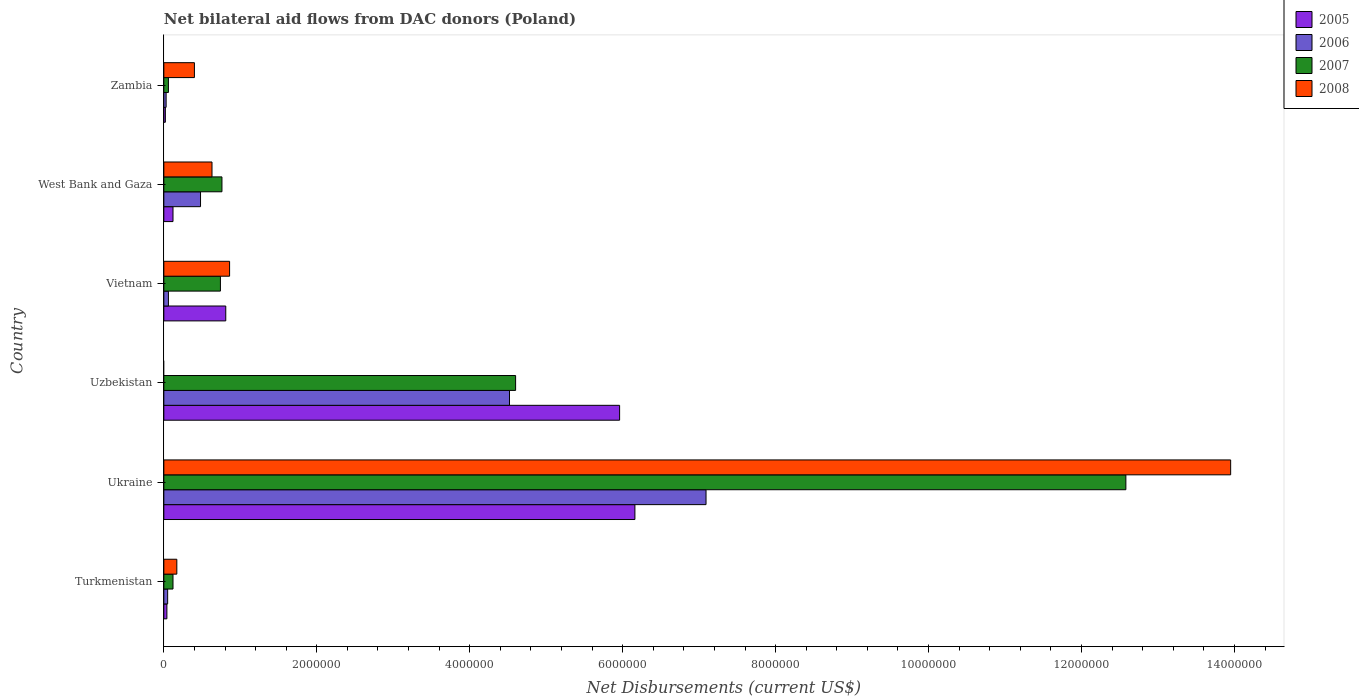How many different coloured bars are there?
Give a very brief answer. 4. Are the number of bars per tick equal to the number of legend labels?
Your answer should be compact. No. What is the label of the 1st group of bars from the top?
Make the answer very short. Zambia. What is the net bilateral aid flows in 2007 in West Bank and Gaza?
Give a very brief answer. 7.60e+05. Across all countries, what is the maximum net bilateral aid flows in 2008?
Provide a succinct answer. 1.40e+07. In which country was the net bilateral aid flows in 2005 maximum?
Provide a short and direct response. Ukraine. What is the total net bilateral aid flows in 2008 in the graph?
Provide a succinct answer. 1.60e+07. What is the difference between the net bilateral aid flows in 2006 in Uzbekistan and the net bilateral aid flows in 2007 in Vietnam?
Your answer should be compact. 3.78e+06. What is the average net bilateral aid flows in 2005 per country?
Offer a terse response. 2.18e+06. What is the difference between the net bilateral aid flows in 2008 and net bilateral aid flows in 2007 in Ukraine?
Provide a short and direct response. 1.37e+06. In how many countries, is the net bilateral aid flows in 2005 greater than 4000000 US$?
Give a very brief answer. 2. What is the ratio of the net bilateral aid flows in 2006 in Turkmenistan to that in Zambia?
Your answer should be compact. 1.67. Is the difference between the net bilateral aid flows in 2008 in West Bank and Gaza and Zambia greater than the difference between the net bilateral aid flows in 2007 in West Bank and Gaza and Zambia?
Provide a short and direct response. No. What is the difference between the highest and the second highest net bilateral aid flows in 2006?
Your response must be concise. 2.57e+06. What is the difference between the highest and the lowest net bilateral aid flows in 2007?
Ensure brevity in your answer.  1.25e+07. How many bars are there?
Keep it short and to the point. 23. Are all the bars in the graph horizontal?
Ensure brevity in your answer.  Yes. How many countries are there in the graph?
Provide a succinct answer. 6. What is the difference between two consecutive major ticks on the X-axis?
Ensure brevity in your answer.  2.00e+06. Are the values on the major ticks of X-axis written in scientific E-notation?
Make the answer very short. No. Does the graph contain any zero values?
Ensure brevity in your answer.  Yes. How many legend labels are there?
Make the answer very short. 4. How are the legend labels stacked?
Offer a very short reply. Vertical. What is the title of the graph?
Offer a very short reply. Net bilateral aid flows from DAC donors (Poland). Does "1963" appear as one of the legend labels in the graph?
Your answer should be compact. No. What is the label or title of the X-axis?
Offer a terse response. Net Disbursements (current US$). What is the Net Disbursements (current US$) of 2008 in Turkmenistan?
Your response must be concise. 1.70e+05. What is the Net Disbursements (current US$) in 2005 in Ukraine?
Provide a succinct answer. 6.16e+06. What is the Net Disbursements (current US$) in 2006 in Ukraine?
Keep it short and to the point. 7.09e+06. What is the Net Disbursements (current US$) in 2007 in Ukraine?
Your answer should be very brief. 1.26e+07. What is the Net Disbursements (current US$) in 2008 in Ukraine?
Your answer should be compact. 1.40e+07. What is the Net Disbursements (current US$) in 2005 in Uzbekistan?
Make the answer very short. 5.96e+06. What is the Net Disbursements (current US$) of 2006 in Uzbekistan?
Provide a succinct answer. 4.52e+06. What is the Net Disbursements (current US$) of 2007 in Uzbekistan?
Offer a terse response. 4.60e+06. What is the Net Disbursements (current US$) of 2005 in Vietnam?
Give a very brief answer. 8.10e+05. What is the Net Disbursements (current US$) in 2006 in Vietnam?
Give a very brief answer. 6.00e+04. What is the Net Disbursements (current US$) of 2007 in Vietnam?
Provide a succinct answer. 7.40e+05. What is the Net Disbursements (current US$) in 2008 in Vietnam?
Ensure brevity in your answer.  8.60e+05. What is the Net Disbursements (current US$) in 2007 in West Bank and Gaza?
Your answer should be very brief. 7.60e+05. What is the Net Disbursements (current US$) in 2008 in West Bank and Gaza?
Make the answer very short. 6.30e+05. What is the Net Disbursements (current US$) of 2005 in Zambia?
Your response must be concise. 2.00e+04. What is the Net Disbursements (current US$) of 2006 in Zambia?
Ensure brevity in your answer.  3.00e+04. What is the Net Disbursements (current US$) in 2008 in Zambia?
Your answer should be very brief. 4.00e+05. Across all countries, what is the maximum Net Disbursements (current US$) in 2005?
Ensure brevity in your answer.  6.16e+06. Across all countries, what is the maximum Net Disbursements (current US$) of 2006?
Ensure brevity in your answer.  7.09e+06. Across all countries, what is the maximum Net Disbursements (current US$) in 2007?
Give a very brief answer. 1.26e+07. Across all countries, what is the maximum Net Disbursements (current US$) in 2008?
Your answer should be very brief. 1.40e+07. Across all countries, what is the minimum Net Disbursements (current US$) of 2005?
Give a very brief answer. 2.00e+04. Across all countries, what is the minimum Net Disbursements (current US$) in 2006?
Provide a succinct answer. 3.00e+04. What is the total Net Disbursements (current US$) in 2005 in the graph?
Provide a succinct answer. 1.31e+07. What is the total Net Disbursements (current US$) of 2006 in the graph?
Your answer should be very brief. 1.22e+07. What is the total Net Disbursements (current US$) of 2007 in the graph?
Ensure brevity in your answer.  1.89e+07. What is the total Net Disbursements (current US$) of 2008 in the graph?
Provide a short and direct response. 1.60e+07. What is the difference between the Net Disbursements (current US$) of 2005 in Turkmenistan and that in Ukraine?
Your response must be concise. -6.12e+06. What is the difference between the Net Disbursements (current US$) of 2006 in Turkmenistan and that in Ukraine?
Ensure brevity in your answer.  -7.04e+06. What is the difference between the Net Disbursements (current US$) of 2007 in Turkmenistan and that in Ukraine?
Provide a short and direct response. -1.25e+07. What is the difference between the Net Disbursements (current US$) of 2008 in Turkmenistan and that in Ukraine?
Provide a short and direct response. -1.38e+07. What is the difference between the Net Disbursements (current US$) of 2005 in Turkmenistan and that in Uzbekistan?
Provide a short and direct response. -5.92e+06. What is the difference between the Net Disbursements (current US$) in 2006 in Turkmenistan and that in Uzbekistan?
Your answer should be compact. -4.47e+06. What is the difference between the Net Disbursements (current US$) of 2007 in Turkmenistan and that in Uzbekistan?
Your answer should be compact. -4.48e+06. What is the difference between the Net Disbursements (current US$) in 2005 in Turkmenistan and that in Vietnam?
Offer a very short reply. -7.70e+05. What is the difference between the Net Disbursements (current US$) in 2006 in Turkmenistan and that in Vietnam?
Your answer should be very brief. -10000. What is the difference between the Net Disbursements (current US$) in 2007 in Turkmenistan and that in Vietnam?
Provide a short and direct response. -6.20e+05. What is the difference between the Net Disbursements (current US$) in 2008 in Turkmenistan and that in Vietnam?
Ensure brevity in your answer.  -6.90e+05. What is the difference between the Net Disbursements (current US$) of 2006 in Turkmenistan and that in West Bank and Gaza?
Give a very brief answer. -4.30e+05. What is the difference between the Net Disbursements (current US$) in 2007 in Turkmenistan and that in West Bank and Gaza?
Give a very brief answer. -6.40e+05. What is the difference between the Net Disbursements (current US$) of 2008 in Turkmenistan and that in West Bank and Gaza?
Give a very brief answer. -4.60e+05. What is the difference between the Net Disbursements (current US$) in 2005 in Turkmenistan and that in Zambia?
Offer a very short reply. 2.00e+04. What is the difference between the Net Disbursements (current US$) of 2006 in Turkmenistan and that in Zambia?
Your answer should be compact. 2.00e+04. What is the difference between the Net Disbursements (current US$) of 2008 in Turkmenistan and that in Zambia?
Ensure brevity in your answer.  -2.30e+05. What is the difference between the Net Disbursements (current US$) in 2005 in Ukraine and that in Uzbekistan?
Offer a very short reply. 2.00e+05. What is the difference between the Net Disbursements (current US$) of 2006 in Ukraine and that in Uzbekistan?
Your answer should be compact. 2.57e+06. What is the difference between the Net Disbursements (current US$) of 2007 in Ukraine and that in Uzbekistan?
Your response must be concise. 7.98e+06. What is the difference between the Net Disbursements (current US$) of 2005 in Ukraine and that in Vietnam?
Give a very brief answer. 5.35e+06. What is the difference between the Net Disbursements (current US$) of 2006 in Ukraine and that in Vietnam?
Ensure brevity in your answer.  7.03e+06. What is the difference between the Net Disbursements (current US$) in 2007 in Ukraine and that in Vietnam?
Offer a very short reply. 1.18e+07. What is the difference between the Net Disbursements (current US$) of 2008 in Ukraine and that in Vietnam?
Offer a terse response. 1.31e+07. What is the difference between the Net Disbursements (current US$) in 2005 in Ukraine and that in West Bank and Gaza?
Make the answer very short. 6.04e+06. What is the difference between the Net Disbursements (current US$) in 2006 in Ukraine and that in West Bank and Gaza?
Offer a very short reply. 6.61e+06. What is the difference between the Net Disbursements (current US$) of 2007 in Ukraine and that in West Bank and Gaza?
Your response must be concise. 1.18e+07. What is the difference between the Net Disbursements (current US$) in 2008 in Ukraine and that in West Bank and Gaza?
Provide a succinct answer. 1.33e+07. What is the difference between the Net Disbursements (current US$) in 2005 in Ukraine and that in Zambia?
Your response must be concise. 6.14e+06. What is the difference between the Net Disbursements (current US$) in 2006 in Ukraine and that in Zambia?
Make the answer very short. 7.06e+06. What is the difference between the Net Disbursements (current US$) of 2007 in Ukraine and that in Zambia?
Your answer should be very brief. 1.25e+07. What is the difference between the Net Disbursements (current US$) in 2008 in Ukraine and that in Zambia?
Your answer should be compact. 1.36e+07. What is the difference between the Net Disbursements (current US$) in 2005 in Uzbekistan and that in Vietnam?
Your response must be concise. 5.15e+06. What is the difference between the Net Disbursements (current US$) in 2006 in Uzbekistan and that in Vietnam?
Ensure brevity in your answer.  4.46e+06. What is the difference between the Net Disbursements (current US$) of 2007 in Uzbekistan and that in Vietnam?
Make the answer very short. 3.86e+06. What is the difference between the Net Disbursements (current US$) of 2005 in Uzbekistan and that in West Bank and Gaza?
Offer a very short reply. 5.84e+06. What is the difference between the Net Disbursements (current US$) in 2006 in Uzbekistan and that in West Bank and Gaza?
Offer a terse response. 4.04e+06. What is the difference between the Net Disbursements (current US$) of 2007 in Uzbekistan and that in West Bank and Gaza?
Your answer should be compact. 3.84e+06. What is the difference between the Net Disbursements (current US$) in 2005 in Uzbekistan and that in Zambia?
Provide a short and direct response. 5.94e+06. What is the difference between the Net Disbursements (current US$) of 2006 in Uzbekistan and that in Zambia?
Your response must be concise. 4.49e+06. What is the difference between the Net Disbursements (current US$) of 2007 in Uzbekistan and that in Zambia?
Your response must be concise. 4.54e+06. What is the difference between the Net Disbursements (current US$) in 2005 in Vietnam and that in West Bank and Gaza?
Offer a very short reply. 6.90e+05. What is the difference between the Net Disbursements (current US$) of 2006 in Vietnam and that in West Bank and Gaza?
Your answer should be very brief. -4.20e+05. What is the difference between the Net Disbursements (current US$) in 2007 in Vietnam and that in West Bank and Gaza?
Your answer should be very brief. -2.00e+04. What is the difference between the Net Disbursements (current US$) in 2008 in Vietnam and that in West Bank and Gaza?
Provide a short and direct response. 2.30e+05. What is the difference between the Net Disbursements (current US$) of 2005 in Vietnam and that in Zambia?
Make the answer very short. 7.90e+05. What is the difference between the Net Disbursements (current US$) of 2006 in Vietnam and that in Zambia?
Offer a very short reply. 3.00e+04. What is the difference between the Net Disbursements (current US$) in 2007 in Vietnam and that in Zambia?
Your answer should be very brief. 6.80e+05. What is the difference between the Net Disbursements (current US$) in 2008 in Vietnam and that in Zambia?
Your answer should be compact. 4.60e+05. What is the difference between the Net Disbursements (current US$) of 2005 in West Bank and Gaza and that in Zambia?
Give a very brief answer. 1.00e+05. What is the difference between the Net Disbursements (current US$) in 2007 in West Bank and Gaza and that in Zambia?
Give a very brief answer. 7.00e+05. What is the difference between the Net Disbursements (current US$) in 2008 in West Bank and Gaza and that in Zambia?
Ensure brevity in your answer.  2.30e+05. What is the difference between the Net Disbursements (current US$) of 2005 in Turkmenistan and the Net Disbursements (current US$) of 2006 in Ukraine?
Offer a terse response. -7.05e+06. What is the difference between the Net Disbursements (current US$) in 2005 in Turkmenistan and the Net Disbursements (current US$) in 2007 in Ukraine?
Offer a terse response. -1.25e+07. What is the difference between the Net Disbursements (current US$) of 2005 in Turkmenistan and the Net Disbursements (current US$) of 2008 in Ukraine?
Provide a succinct answer. -1.39e+07. What is the difference between the Net Disbursements (current US$) of 2006 in Turkmenistan and the Net Disbursements (current US$) of 2007 in Ukraine?
Make the answer very short. -1.25e+07. What is the difference between the Net Disbursements (current US$) in 2006 in Turkmenistan and the Net Disbursements (current US$) in 2008 in Ukraine?
Ensure brevity in your answer.  -1.39e+07. What is the difference between the Net Disbursements (current US$) of 2007 in Turkmenistan and the Net Disbursements (current US$) of 2008 in Ukraine?
Your response must be concise. -1.38e+07. What is the difference between the Net Disbursements (current US$) in 2005 in Turkmenistan and the Net Disbursements (current US$) in 2006 in Uzbekistan?
Offer a very short reply. -4.48e+06. What is the difference between the Net Disbursements (current US$) of 2005 in Turkmenistan and the Net Disbursements (current US$) of 2007 in Uzbekistan?
Your response must be concise. -4.56e+06. What is the difference between the Net Disbursements (current US$) in 2006 in Turkmenistan and the Net Disbursements (current US$) in 2007 in Uzbekistan?
Give a very brief answer. -4.55e+06. What is the difference between the Net Disbursements (current US$) of 2005 in Turkmenistan and the Net Disbursements (current US$) of 2006 in Vietnam?
Offer a very short reply. -2.00e+04. What is the difference between the Net Disbursements (current US$) of 2005 in Turkmenistan and the Net Disbursements (current US$) of 2007 in Vietnam?
Offer a terse response. -7.00e+05. What is the difference between the Net Disbursements (current US$) of 2005 in Turkmenistan and the Net Disbursements (current US$) of 2008 in Vietnam?
Your answer should be compact. -8.20e+05. What is the difference between the Net Disbursements (current US$) of 2006 in Turkmenistan and the Net Disbursements (current US$) of 2007 in Vietnam?
Keep it short and to the point. -6.90e+05. What is the difference between the Net Disbursements (current US$) of 2006 in Turkmenistan and the Net Disbursements (current US$) of 2008 in Vietnam?
Make the answer very short. -8.10e+05. What is the difference between the Net Disbursements (current US$) of 2007 in Turkmenistan and the Net Disbursements (current US$) of 2008 in Vietnam?
Your answer should be very brief. -7.40e+05. What is the difference between the Net Disbursements (current US$) in 2005 in Turkmenistan and the Net Disbursements (current US$) in 2006 in West Bank and Gaza?
Ensure brevity in your answer.  -4.40e+05. What is the difference between the Net Disbursements (current US$) of 2005 in Turkmenistan and the Net Disbursements (current US$) of 2007 in West Bank and Gaza?
Your answer should be compact. -7.20e+05. What is the difference between the Net Disbursements (current US$) in 2005 in Turkmenistan and the Net Disbursements (current US$) in 2008 in West Bank and Gaza?
Your answer should be very brief. -5.90e+05. What is the difference between the Net Disbursements (current US$) of 2006 in Turkmenistan and the Net Disbursements (current US$) of 2007 in West Bank and Gaza?
Ensure brevity in your answer.  -7.10e+05. What is the difference between the Net Disbursements (current US$) in 2006 in Turkmenistan and the Net Disbursements (current US$) in 2008 in West Bank and Gaza?
Offer a very short reply. -5.80e+05. What is the difference between the Net Disbursements (current US$) of 2007 in Turkmenistan and the Net Disbursements (current US$) of 2008 in West Bank and Gaza?
Your response must be concise. -5.10e+05. What is the difference between the Net Disbursements (current US$) of 2005 in Turkmenistan and the Net Disbursements (current US$) of 2007 in Zambia?
Ensure brevity in your answer.  -2.00e+04. What is the difference between the Net Disbursements (current US$) in 2005 in Turkmenistan and the Net Disbursements (current US$) in 2008 in Zambia?
Your answer should be compact. -3.60e+05. What is the difference between the Net Disbursements (current US$) in 2006 in Turkmenistan and the Net Disbursements (current US$) in 2008 in Zambia?
Make the answer very short. -3.50e+05. What is the difference between the Net Disbursements (current US$) of 2007 in Turkmenistan and the Net Disbursements (current US$) of 2008 in Zambia?
Offer a very short reply. -2.80e+05. What is the difference between the Net Disbursements (current US$) in 2005 in Ukraine and the Net Disbursements (current US$) in 2006 in Uzbekistan?
Your response must be concise. 1.64e+06. What is the difference between the Net Disbursements (current US$) of 2005 in Ukraine and the Net Disbursements (current US$) of 2007 in Uzbekistan?
Your answer should be compact. 1.56e+06. What is the difference between the Net Disbursements (current US$) of 2006 in Ukraine and the Net Disbursements (current US$) of 2007 in Uzbekistan?
Your answer should be compact. 2.49e+06. What is the difference between the Net Disbursements (current US$) in 2005 in Ukraine and the Net Disbursements (current US$) in 2006 in Vietnam?
Provide a succinct answer. 6.10e+06. What is the difference between the Net Disbursements (current US$) of 2005 in Ukraine and the Net Disbursements (current US$) of 2007 in Vietnam?
Make the answer very short. 5.42e+06. What is the difference between the Net Disbursements (current US$) in 2005 in Ukraine and the Net Disbursements (current US$) in 2008 in Vietnam?
Ensure brevity in your answer.  5.30e+06. What is the difference between the Net Disbursements (current US$) in 2006 in Ukraine and the Net Disbursements (current US$) in 2007 in Vietnam?
Your answer should be very brief. 6.35e+06. What is the difference between the Net Disbursements (current US$) in 2006 in Ukraine and the Net Disbursements (current US$) in 2008 in Vietnam?
Offer a terse response. 6.23e+06. What is the difference between the Net Disbursements (current US$) in 2007 in Ukraine and the Net Disbursements (current US$) in 2008 in Vietnam?
Your answer should be very brief. 1.17e+07. What is the difference between the Net Disbursements (current US$) of 2005 in Ukraine and the Net Disbursements (current US$) of 2006 in West Bank and Gaza?
Your answer should be very brief. 5.68e+06. What is the difference between the Net Disbursements (current US$) in 2005 in Ukraine and the Net Disbursements (current US$) in 2007 in West Bank and Gaza?
Your answer should be very brief. 5.40e+06. What is the difference between the Net Disbursements (current US$) of 2005 in Ukraine and the Net Disbursements (current US$) of 2008 in West Bank and Gaza?
Your response must be concise. 5.53e+06. What is the difference between the Net Disbursements (current US$) of 2006 in Ukraine and the Net Disbursements (current US$) of 2007 in West Bank and Gaza?
Provide a succinct answer. 6.33e+06. What is the difference between the Net Disbursements (current US$) in 2006 in Ukraine and the Net Disbursements (current US$) in 2008 in West Bank and Gaza?
Your response must be concise. 6.46e+06. What is the difference between the Net Disbursements (current US$) in 2007 in Ukraine and the Net Disbursements (current US$) in 2008 in West Bank and Gaza?
Offer a terse response. 1.20e+07. What is the difference between the Net Disbursements (current US$) of 2005 in Ukraine and the Net Disbursements (current US$) of 2006 in Zambia?
Offer a very short reply. 6.13e+06. What is the difference between the Net Disbursements (current US$) of 2005 in Ukraine and the Net Disbursements (current US$) of 2007 in Zambia?
Offer a terse response. 6.10e+06. What is the difference between the Net Disbursements (current US$) of 2005 in Ukraine and the Net Disbursements (current US$) of 2008 in Zambia?
Your answer should be compact. 5.76e+06. What is the difference between the Net Disbursements (current US$) of 2006 in Ukraine and the Net Disbursements (current US$) of 2007 in Zambia?
Offer a very short reply. 7.03e+06. What is the difference between the Net Disbursements (current US$) of 2006 in Ukraine and the Net Disbursements (current US$) of 2008 in Zambia?
Your response must be concise. 6.69e+06. What is the difference between the Net Disbursements (current US$) of 2007 in Ukraine and the Net Disbursements (current US$) of 2008 in Zambia?
Offer a terse response. 1.22e+07. What is the difference between the Net Disbursements (current US$) of 2005 in Uzbekistan and the Net Disbursements (current US$) of 2006 in Vietnam?
Your answer should be very brief. 5.90e+06. What is the difference between the Net Disbursements (current US$) of 2005 in Uzbekistan and the Net Disbursements (current US$) of 2007 in Vietnam?
Give a very brief answer. 5.22e+06. What is the difference between the Net Disbursements (current US$) in 2005 in Uzbekistan and the Net Disbursements (current US$) in 2008 in Vietnam?
Provide a succinct answer. 5.10e+06. What is the difference between the Net Disbursements (current US$) of 2006 in Uzbekistan and the Net Disbursements (current US$) of 2007 in Vietnam?
Offer a very short reply. 3.78e+06. What is the difference between the Net Disbursements (current US$) of 2006 in Uzbekistan and the Net Disbursements (current US$) of 2008 in Vietnam?
Your response must be concise. 3.66e+06. What is the difference between the Net Disbursements (current US$) of 2007 in Uzbekistan and the Net Disbursements (current US$) of 2008 in Vietnam?
Provide a short and direct response. 3.74e+06. What is the difference between the Net Disbursements (current US$) of 2005 in Uzbekistan and the Net Disbursements (current US$) of 2006 in West Bank and Gaza?
Provide a short and direct response. 5.48e+06. What is the difference between the Net Disbursements (current US$) of 2005 in Uzbekistan and the Net Disbursements (current US$) of 2007 in West Bank and Gaza?
Your response must be concise. 5.20e+06. What is the difference between the Net Disbursements (current US$) of 2005 in Uzbekistan and the Net Disbursements (current US$) of 2008 in West Bank and Gaza?
Offer a terse response. 5.33e+06. What is the difference between the Net Disbursements (current US$) of 2006 in Uzbekistan and the Net Disbursements (current US$) of 2007 in West Bank and Gaza?
Ensure brevity in your answer.  3.76e+06. What is the difference between the Net Disbursements (current US$) in 2006 in Uzbekistan and the Net Disbursements (current US$) in 2008 in West Bank and Gaza?
Keep it short and to the point. 3.89e+06. What is the difference between the Net Disbursements (current US$) of 2007 in Uzbekistan and the Net Disbursements (current US$) of 2008 in West Bank and Gaza?
Provide a succinct answer. 3.97e+06. What is the difference between the Net Disbursements (current US$) of 2005 in Uzbekistan and the Net Disbursements (current US$) of 2006 in Zambia?
Your response must be concise. 5.93e+06. What is the difference between the Net Disbursements (current US$) of 2005 in Uzbekistan and the Net Disbursements (current US$) of 2007 in Zambia?
Your response must be concise. 5.90e+06. What is the difference between the Net Disbursements (current US$) of 2005 in Uzbekistan and the Net Disbursements (current US$) of 2008 in Zambia?
Offer a terse response. 5.56e+06. What is the difference between the Net Disbursements (current US$) in 2006 in Uzbekistan and the Net Disbursements (current US$) in 2007 in Zambia?
Your answer should be compact. 4.46e+06. What is the difference between the Net Disbursements (current US$) in 2006 in Uzbekistan and the Net Disbursements (current US$) in 2008 in Zambia?
Offer a very short reply. 4.12e+06. What is the difference between the Net Disbursements (current US$) in 2007 in Uzbekistan and the Net Disbursements (current US$) in 2008 in Zambia?
Make the answer very short. 4.20e+06. What is the difference between the Net Disbursements (current US$) of 2006 in Vietnam and the Net Disbursements (current US$) of 2007 in West Bank and Gaza?
Provide a short and direct response. -7.00e+05. What is the difference between the Net Disbursements (current US$) of 2006 in Vietnam and the Net Disbursements (current US$) of 2008 in West Bank and Gaza?
Make the answer very short. -5.70e+05. What is the difference between the Net Disbursements (current US$) in 2005 in Vietnam and the Net Disbursements (current US$) in 2006 in Zambia?
Your response must be concise. 7.80e+05. What is the difference between the Net Disbursements (current US$) in 2005 in Vietnam and the Net Disbursements (current US$) in 2007 in Zambia?
Offer a terse response. 7.50e+05. What is the difference between the Net Disbursements (current US$) in 2006 in Vietnam and the Net Disbursements (current US$) in 2007 in Zambia?
Keep it short and to the point. 0. What is the difference between the Net Disbursements (current US$) in 2006 in Vietnam and the Net Disbursements (current US$) in 2008 in Zambia?
Your response must be concise. -3.40e+05. What is the difference between the Net Disbursements (current US$) in 2005 in West Bank and Gaza and the Net Disbursements (current US$) in 2008 in Zambia?
Make the answer very short. -2.80e+05. What is the difference between the Net Disbursements (current US$) of 2007 in West Bank and Gaza and the Net Disbursements (current US$) of 2008 in Zambia?
Provide a short and direct response. 3.60e+05. What is the average Net Disbursements (current US$) of 2005 per country?
Your response must be concise. 2.18e+06. What is the average Net Disbursements (current US$) of 2006 per country?
Provide a succinct answer. 2.04e+06. What is the average Net Disbursements (current US$) in 2007 per country?
Your answer should be compact. 3.14e+06. What is the average Net Disbursements (current US$) of 2008 per country?
Offer a terse response. 2.67e+06. What is the difference between the Net Disbursements (current US$) in 2005 and Net Disbursements (current US$) in 2008 in Turkmenistan?
Make the answer very short. -1.30e+05. What is the difference between the Net Disbursements (current US$) of 2006 and Net Disbursements (current US$) of 2008 in Turkmenistan?
Make the answer very short. -1.20e+05. What is the difference between the Net Disbursements (current US$) in 2007 and Net Disbursements (current US$) in 2008 in Turkmenistan?
Provide a short and direct response. -5.00e+04. What is the difference between the Net Disbursements (current US$) in 2005 and Net Disbursements (current US$) in 2006 in Ukraine?
Ensure brevity in your answer.  -9.30e+05. What is the difference between the Net Disbursements (current US$) of 2005 and Net Disbursements (current US$) of 2007 in Ukraine?
Your answer should be compact. -6.42e+06. What is the difference between the Net Disbursements (current US$) in 2005 and Net Disbursements (current US$) in 2008 in Ukraine?
Ensure brevity in your answer.  -7.79e+06. What is the difference between the Net Disbursements (current US$) in 2006 and Net Disbursements (current US$) in 2007 in Ukraine?
Keep it short and to the point. -5.49e+06. What is the difference between the Net Disbursements (current US$) of 2006 and Net Disbursements (current US$) of 2008 in Ukraine?
Your answer should be very brief. -6.86e+06. What is the difference between the Net Disbursements (current US$) of 2007 and Net Disbursements (current US$) of 2008 in Ukraine?
Ensure brevity in your answer.  -1.37e+06. What is the difference between the Net Disbursements (current US$) of 2005 and Net Disbursements (current US$) of 2006 in Uzbekistan?
Give a very brief answer. 1.44e+06. What is the difference between the Net Disbursements (current US$) in 2005 and Net Disbursements (current US$) in 2007 in Uzbekistan?
Your answer should be compact. 1.36e+06. What is the difference between the Net Disbursements (current US$) in 2006 and Net Disbursements (current US$) in 2007 in Uzbekistan?
Ensure brevity in your answer.  -8.00e+04. What is the difference between the Net Disbursements (current US$) of 2005 and Net Disbursements (current US$) of 2006 in Vietnam?
Ensure brevity in your answer.  7.50e+05. What is the difference between the Net Disbursements (current US$) in 2006 and Net Disbursements (current US$) in 2007 in Vietnam?
Offer a terse response. -6.80e+05. What is the difference between the Net Disbursements (current US$) in 2006 and Net Disbursements (current US$) in 2008 in Vietnam?
Keep it short and to the point. -8.00e+05. What is the difference between the Net Disbursements (current US$) in 2005 and Net Disbursements (current US$) in 2006 in West Bank and Gaza?
Your answer should be compact. -3.60e+05. What is the difference between the Net Disbursements (current US$) of 2005 and Net Disbursements (current US$) of 2007 in West Bank and Gaza?
Your answer should be compact. -6.40e+05. What is the difference between the Net Disbursements (current US$) of 2005 and Net Disbursements (current US$) of 2008 in West Bank and Gaza?
Your answer should be very brief. -5.10e+05. What is the difference between the Net Disbursements (current US$) in 2006 and Net Disbursements (current US$) in 2007 in West Bank and Gaza?
Your answer should be very brief. -2.80e+05. What is the difference between the Net Disbursements (current US$) in 2006 and Net Disbursements (current US$) in 2008 in West Bank and Gaza?
Provide a short and direct response. -1.50e+05. What is the difference between the Net Disbursements (current US$) of 2005 and Net Disbursements (current US$) of 2006 in Zambia?
Provide a succinct answer. -10000. What is the difference between the Net Disbursements (current US$) of 2005 and Net Disbursements (current US$) of 2007 in Zambia?
Provide a succinct answer. -4.00e+04. What is the difference between the Net Disbursements (current US$) in 2005 and Net Disbursements (current US$) in 2008 in Zambia?
Make the answer very short. -3.80e+05. What is the difference between the Net Disbursements (current US$) in 2006 and Net Disbursements (current US$) in 2008 in Zambia?
Provide a short and direct response. -3.70e+05. What is the difference between the Net Disbursements (current US$) in 2007 and Net Disbursements (current US$) in 2008 in Zambia?
Your answer should be very brief. -3.40e+05. What is the ratio of the Net Disbursements (current US$) in 2005 in Turkmenistan to that in Ukraine?
Give a very brief answer. 0.01. What is the ratio of the Net Disbursements (current US$) of 2006 in Turkmenistan to that in Ukraine?
Your answer should be compact. 0.01. What is the ratio of the Net Disbursements (current US$) in 2007 in Turkmenistan to that in Ukraine?
Your answer should be compact. 0.01. What is the ratio of the Net Disbursements (current US$) in 2008 in Turkmenistan to that in Ukraine?
Provide a short and direct response. 0.01. What is the ratio of the Net Disbursements (current US$) in 2005 in Turkmenistan to that in Uzbekistan?
Give a very brief answer. 0.01. What is the ratio of the Net Disbursements (current US$) of 2006 in Turkmenistan to that in Uzbekistan?
Offer a terse response. 0.01. What is the ratio of the Net Disbursements (current US$) of 2007 in Turkmenistan to that in Uzbekistan?
Provide a short and direct response. 0.03. What is the ratio of the Net Disbursements (current US$) in 2005 in Turkmenistan to that in Vietnam?
Give a very brief answer. 0.05. What is the ratio of the Net Disbursements (current US$) of 2007 in Turkmenistan to that in Vietnam?
Offer a very short reply. 0.16. What is the ratio of the Net Disbursements (current US$) of 2008 in Turkmenistan to that in Vietnam?
Make the answer very short. 0.2. What is the ratio of the Net Disbursements (current US$) of 2005 in Turkmenistan to that in West Bank and Gaza?
Offer a terse response. 0.33. What is the ratio of the Net Disbursements (current US$) of 2006 in Turkmenistan to that in West Bank and Gaza?
Offer a very short reply. 0.1. What is the ratio of the Net Disbursements (current US$) of 2007 in Turkmenistan to that in West Bank and Gaza?
Your answer should be compact. 0.16. What is the ratio of the Net Disbursements (current US$) in 2008 in Turkmenistan to that in West Bank and Gaza?
Offer a very short reply. 0.27. What is the ratio of the Net Disbursements (current US$) in 2005 in Turkmenistan to that in Zambia?
Keep it short and to the point. 2. What is the ratio of the Net Disbursements (current US$) of 2006 in Turkmenistan to that in Zambia?
Your answer should be compact. 1.67. What is the ratio of the Net Disbursements (current US$) in 2008 in Turkmenistan to that in Zambia?
Ensure brevity in your answer.  0.42. What is the ratio of the Net Disbursements (current US$) of 2005 in Ukraine to that in Uzbekistan?
Provide a short and direct response. 1.03. What is the ratio of the Net Disbursements (current US$) in 2006 in Ukraine to that in Uzbekistan?
Provide a succinct answer. 1.57. What is the ratio of the Net Disbursements (current US$) of 2007 in Ukraine to that in Uzbekistan?
Provide a short and direct response. 2.73. What is the ratio of the Net Disbursements (current US$) of 2005 in Ukraine to that in Vietnam?
Your response must be concise. 7.6. What is the ratio of the Net Disbursements (current US$) in 2006 in Ukraine to that in Vietnam?
Your answer should be compact. 118.17. What is the ratio of the Net Disbursements (current US$) of 2008 in Ukraine to that in Vietnam?
Offer a very short reply. 16.22. What is the ratio of the Net Disbursements (current US$) in 2005 in Ukraine to that in West Bank and Gaza?
Give a very brief answer. 51.33. What is the ratio of the Net Disbursements (current US$) in 2006 in Ukraine to that in West Bank and Gaza?
Provide a succinct answer. 14.77. What is the ratio of the Net Disbursements (current US$) of 2007 in Ukraine to that in West Bank and Gaza?
Provide a succinct answer. 16.55. What is the ratio of the Net Disbursements (current US$) of 2008 in Ukraine to that in West Bank and Gaza?
Your response must be concise. 22.14. What is the ratio of the Net Disbursements (current US$) in 2005 in Ukraine to that in Zambia?
Provide a short and direct response. 308. What is the ratio of the Net Disbursements (current US$) of 2006 in Ukraine to that in Zambia?
Provide a succinct answer. 236.33. What is the ratio of the Net Disbursements (current US$) of 2007 in Ukraine to that in Zambia?
Your answer should be compact. 209.67. What is the ratio of the Net Disbursements (current US$) of 2008 in Ukraine to that in Zambia?
Offer a very short reply. 34.88. What is the ratio of the Net Disbursements (current US$) in 2005 in Uzbekistan to that in Vietnam?
Offer a terse response. 7.36. What is the ratio of the Net Disbursements (current US$) of 2006 in Uzbekistan to that in Vietnam?
Offer a very short reply. 75.33. What is the ratio of the Net Disbursements (current US$) of 2007 in Uzbekistan to that in Vietnam?
Provide a succinct answer. 6.22. What is the ratio of the Net Disbursements (current US$) in 2005 in Uzbekistan to that in West Bank and Gaza?
Give a very brief answer. 49.67. What is the ratio of the Net Disbursements (current US$) of 2006 in Uzbekistan to that in West Bank and Gaza?
Provide a short and direct response. 9.42. What is the ratio of the Net Disbursements (current US$) in 2007 in Uzbekistan to that in West Bank and Gaza?
Ensure brevity in your answer.  6.05. What is the ratio of the Net Disbursements (current US$) in 2005 in Uzbekistan to that in Zambia?
Your answer should be very brief. 298. What is the ratio of the Net Disbursements (current US$) of 2006 in Uzbekistan to that in Zambia?
Your answer should be compact. 150.67. What is the ratio of the Net Disbursements (current US$) in 2007 in Uzbekistan to that in Zambia?
Make the answer very short. 76.67. What is the ratio of the Net Disbursements (current US$) in 2005 in Vietnam to that in West Bank and Gaza?
Provide a succinct answer. 6.75. What is the ratio of the Net Disbursements (current US$) in 2006 in Vietnam to that in West Bank and Gaza?
Keep it short and to the point. 0.12. What is the ratio of the Net Disbursements (current US$) in 2007 in Vietnam to that in West Bank and Gaza?
Your response must be concise. 0.97. What is the ratio of the Net Disbursements (current US$) in 2008 in Vietnam to that in West Bank and Gaza?
Your answer should be very brief. 1.37. What is the ratio of the Net Disbursements (current US$) in 2005 in Vietnam to that in Zambia?
Offer a very short reply. 40.5. What is the ratio of the Net Disbursements (current US$) in 2007 in Vietnam to that in Zambia?
Provide a succinct answer. 12.33. What is the ratio of the Net Disbursements (current US$) in 2008 in Vietnam to that in Zambia?
Your answer should be very brief. 2.15. What is the ratio of the Net Disbursements (current US$) in 2007 in West Bank and Gaza to that in Zambia?
Ensure brevity in your answer.  12.67. What is the ratio of the Net Disbursements (current US$) of 2008 in West Bank and Gaza to that in Zambia?
Provide a short and direct response. 1.57. What is the difference between the highest and the second highest Net Disbursements (current US$) of 2005?
Give a very brief answer. 2.00e+05. What is the difference between the highest and the second highest Net Disbursements (current US$) in 2006?
Provide a succinct answer. 2.57e+06. What is the difference between the highest and the second highest Net Disbursements (current US$) in 2007?
Your response must be concise. 7.98e+06. What is the difference between the highest and the second highest Net Disbursements (current US$) of 2008?
Your answer should be compact. 1.31e+07. What is the difference between the highest and the lowest Net Disbursements (current US$) in 2005?
Your answer should be very brief. 6.14e+06. What is the difference between the highest and the lowest Net Disbursements (current US$) in 2006?
Your answer should be compact. 7.06e+06. What is the difference between the highest and the lowest Net Disbursements (current US$) of 2007?
Provide a succinct answer. 1.25e+07. What is the difference between the highest and the lowest Net Disbursements (current US$) of 2008?
Offer a terse response. 1.40e+07. 